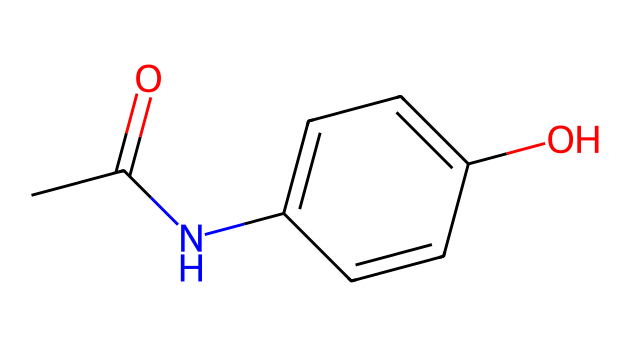What is the molecular formula of paracetamol? By analyzing the structure represented by the given SMILES notation, we can count the atoms: there are 8 carbons, 9 hydrogens, 1 nitrogen, and 2 oxygens. Therefore, the molecular formula can be formulated as C8H9NO2.
Answer: C8H9NO2 How many rings are present in the paracetamol structure? Looking at the chemical structure, it has one benzene ring which is a six-membered ring with alternating single and double bonds. Therefore, there is 1 ring in the structure.
Answer: 1 What functional groups are present in paracetamol? Examining the chemical structure shows the presence of an amide group (due to the nitrogen and carbonyl), a hydroxyl group (due to the -OH), and a carbonyl group. Therefore, the functional groups present are amide, hydroxyl, and carbonyl.
Answer: amide, hydroxyl, carbonyl What is the position of the hydroxyl group on the aromatic ring? The structure indicates that the hydroxyl group (-OH) is attached to the para position of the benzene ring relative to the nitrogen atom. In terms of numbering, if nitrogen is at position 1, the hydroxyl is at position 4.
Answer: para What is the total number of hydrogen atoms in paracetamol? By looking at both the hydrogen atoms directly bonded to carbon in the structure and considering the functional groups, we can see a total of 9 hydrogen atoms present overall in the chemical structure.
Answer: 9 What type of compound is paracetamol classified as? Paracetamol is classified as an analgesic and antipyretic drug. This classification can be deduced from its structure, which is typical for non-opioid pain-relieving compounds.
Answer: analgesic, antipyretic 